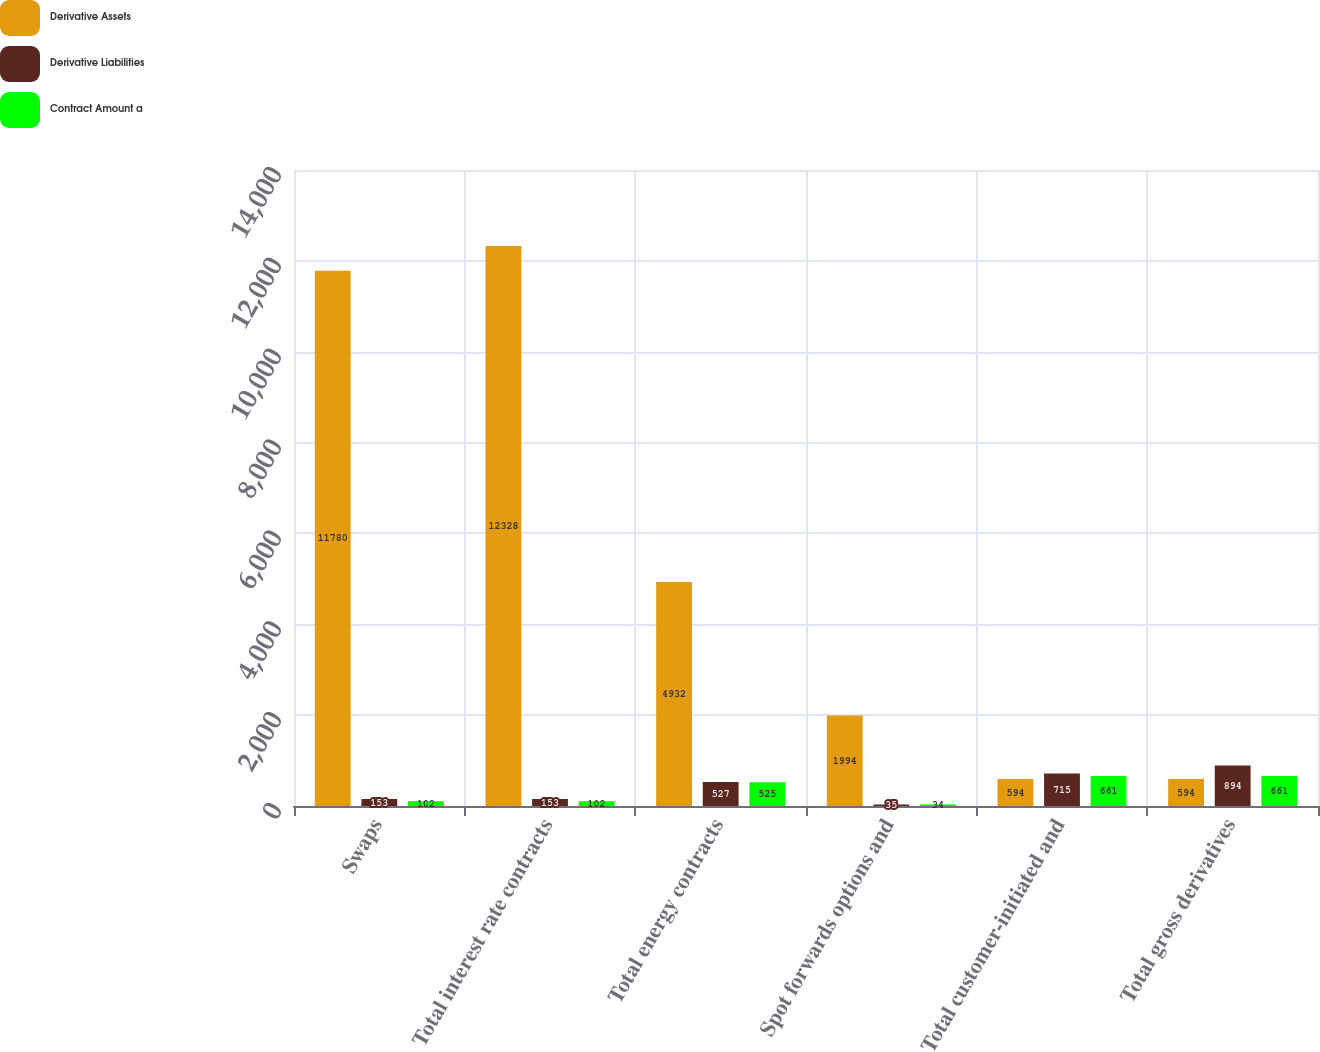Convert chart. <chart><loc_0><loc_0><loc_500><loc_500><stacked_bar_chart><ecel><fcel>Swaps<fcel>Total interest rate contracts<fcel>Total energy contracts<fcel>Spot forwards options and<fcel>Total customer-initiated and<fcel>Total gross derivatives<nl><fcel>Derivative Assets<fcel>11780<fcel>12328<fcel>4932<fcel>1994<fcel>594<fcel>594<nl><fcel>Derivative Liabilities<fcel>153<fcel>153<fcel>527<fcel>35<fcel>715<fcel>894<nl><fcel>Contract Amount a<fcel>102<fcel>102<fcel>525<fcel>34<fcel>661<fcel>661<nl></chart> 